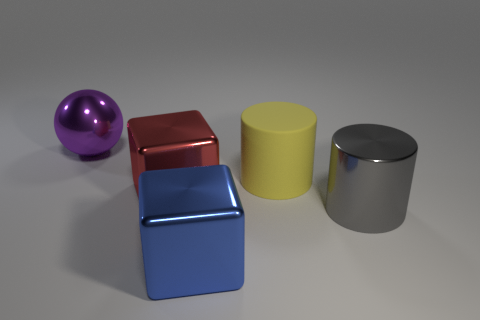Could you describe the lighting and shadows in the scene? The image showcases a subtle, diffused lighting coming from the upper left, resulting in soft, muted shadows to the right of the objects. This kind of lighting suggests an overcast day or soft-box lighting in a studio setup. It creates a calm atmosphere and allows the colors and shapes of the objects to stand out. 